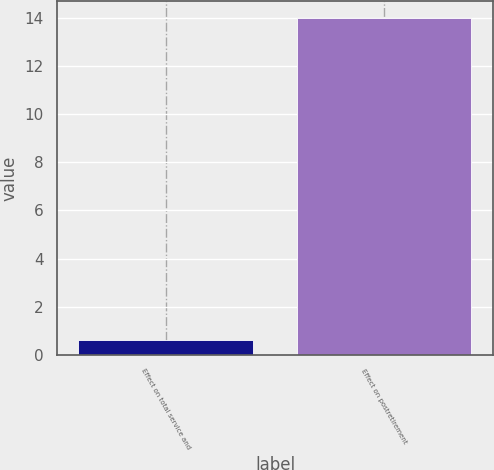Convert chart. <chart><loc_0><loc_0><loc_500><loc_500><bar_chart><fcel>Effect on total service and<fcel>Effect on postretirement<nl><fcel>0.6<fcel>14<nl></chart> 